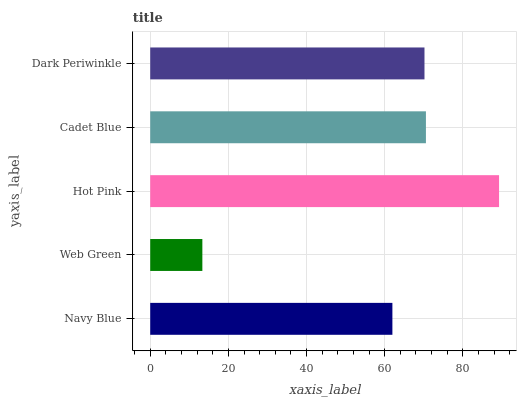Is Web Green the minimum?
Answer yes or no. Yes. Is Hot Pink the maximum?
Answer yes or no. Yes. Is Hot Pink the minimum?
Answer yes or no. No. Is Web Green the maximum?
Answer yes or no. No. Is Hot Pink greater than Web Green?
Answer yes or no. Yes. Is Web Green less than Hot Pink?
Answer yes or no. Yes. Is Web Green greater than Hot Pink?
Answer yes or no. No. Is Hot Pink less than Web Green?
Answer yes or no. No. Is Dark Periwinkle the high median?
Answer yes or no. Yes. Is Dark Periwinkle the low median?
Answer yes or no. Yes. Is Hot Pink the high median?
Answer yes or no. No. Is Hot Pink the low median?
Answer yes or no. No. 